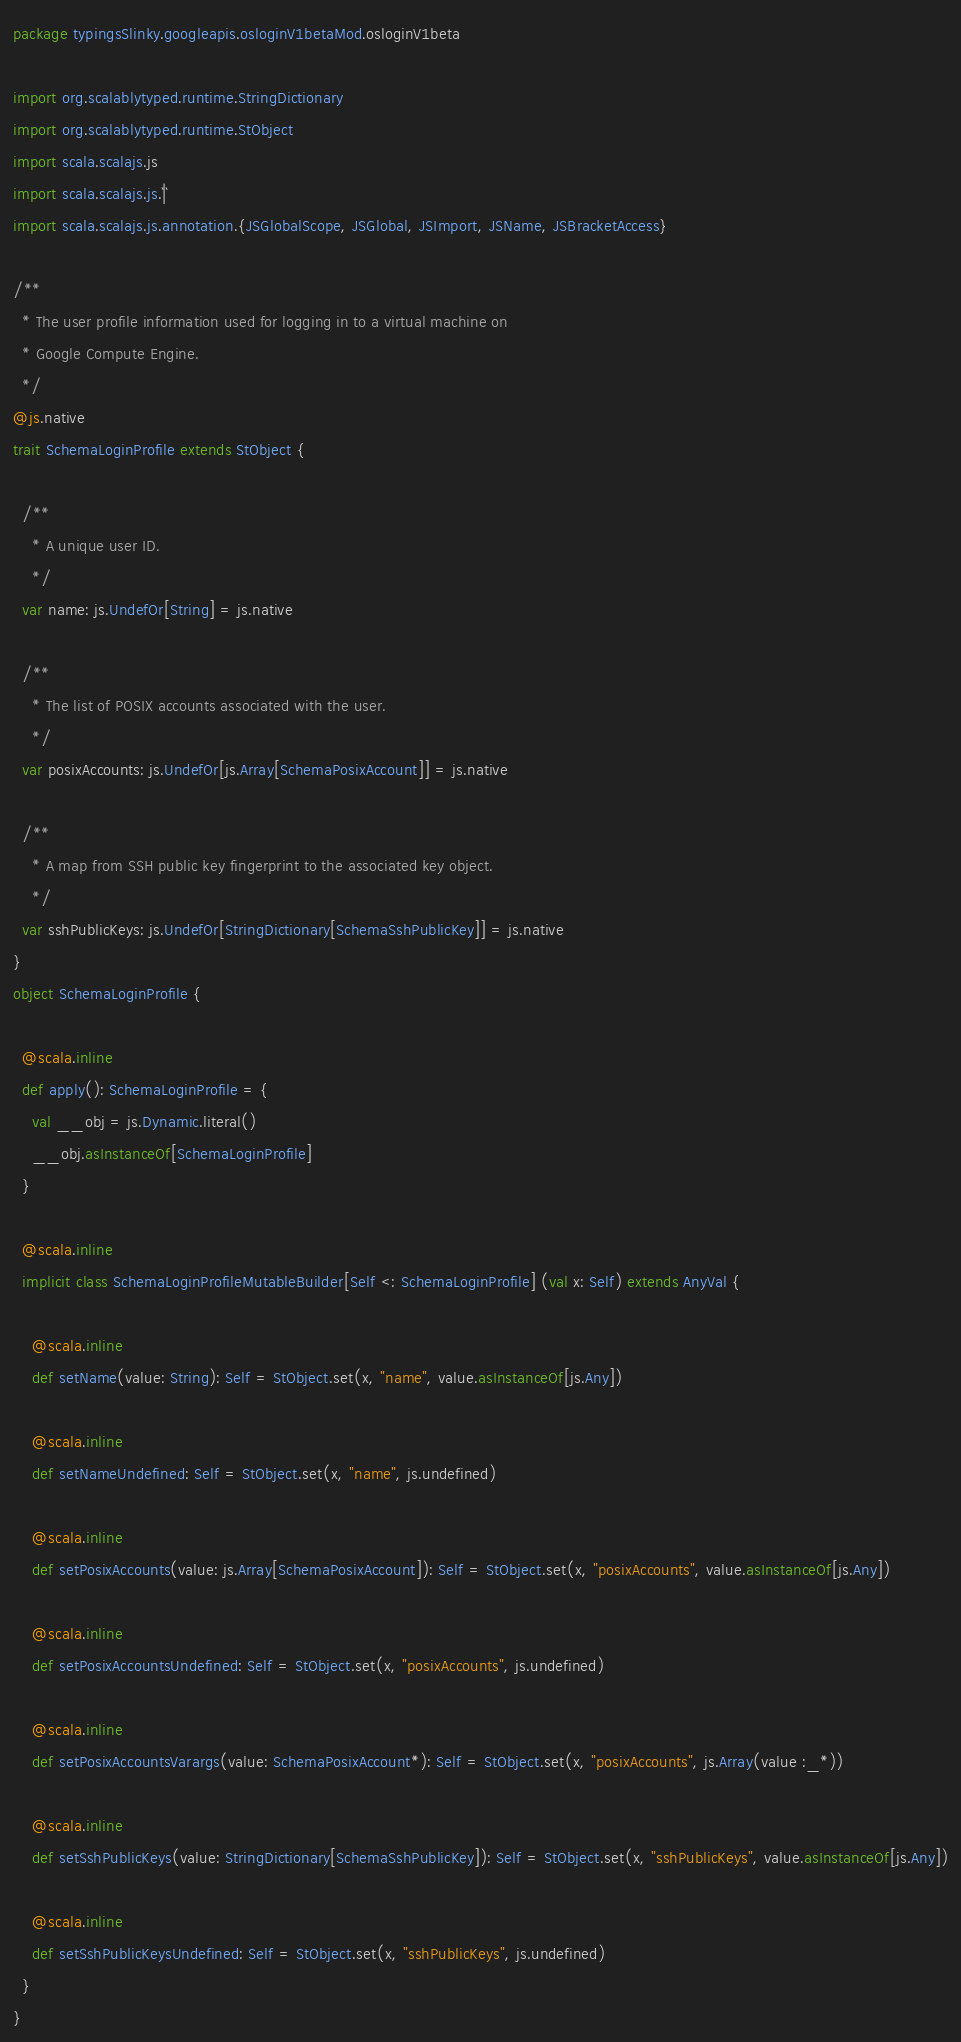<code> <loc_0><loc_0><loc_500><loc_500><_Scala_>package typingsSlinky.googleapis.osloginV1betaMod.osloginV1beta

import org.scalablytyped.runtime.StringDictionary
import org.scalablytyped.runtime.StObject
import scala.scalajs.js
import scala.scalajs.js.`|`
import scala.scalajs.js.annotation.{JSGlobalScope, JSGlobal, JSImport, JSName, JSBracketAccess}

/**
  * The user profile information used for logging in to a virtual machine on
  * Google Compute Engine.
  */
@js.native
trait SchemaLoginProfile extends StObject {
  
  /**
    * A unique user ID.
    */
  var name: js.UndefOr[String] = js.native
  
  /**
    * The list of POSIX accounts associated with the user.
    */
  var posixAccounts: js.UndefOr[js.Array[SchemaPosixAccount]] = js.native
  
  /**
    * A map from SSH public key fingerprint to the associated key object.
    */
  var sshPublicKeys: js.UndefOr[StringDictionary[SchemaSshPublicKey]] = js.native
}
object SchemaLoginProfile {
  
  @scala.inline
  def apply(): SchemaLoginProfile = {
    val __obj = js.Dynamic.literal()
    __obj.asInstanceOf[SchemaLoginProfile]
  }
  
  @scala.inline
  implicit class SchemaLoginProfileMutableBuilder[Self <: SchemaLoginProfile] (val x: Self) extends AnyVal {
    
    @scala.inline
    def setName(value: String): Self = StObject.set(x, "name", value.asInstanceOf[js.Any])
    
    @scala.inline
    def setNameUndefined: Self = StObject.set(x, "name", js.undefined)
    
    @scala.inline
    def setPosixAccounts(value: js.Array[SchemaPosixAccount]): Self = StObject.set(x, "posixAccounts", value.asInstanceOf[js.Any])
    
    @scala.inline
    def setPosixAccountsUndefined: Self = StObject.set(x, "posixAccounts", js.undefined)
    
    @scala.inline
    def setPosixAccountsVarargs(value: SchemaPosixAccount*): Self = StObject.set(x, "posixAccounts", js.Array(value :_*))
    
    @scala.inline
    def setSshPublicKeys(value: StringDictionary[SchemaSshPublicKey]): Self = StObject.set(x, "sshPublicKeys", value.asInstanceOf[js.Any])
    
    @scala.inline
    def setSshPublicKeysUndefined: Self = StObject.set(x, "sshPublicKeys", js.undefined)
  }
}
</code> 